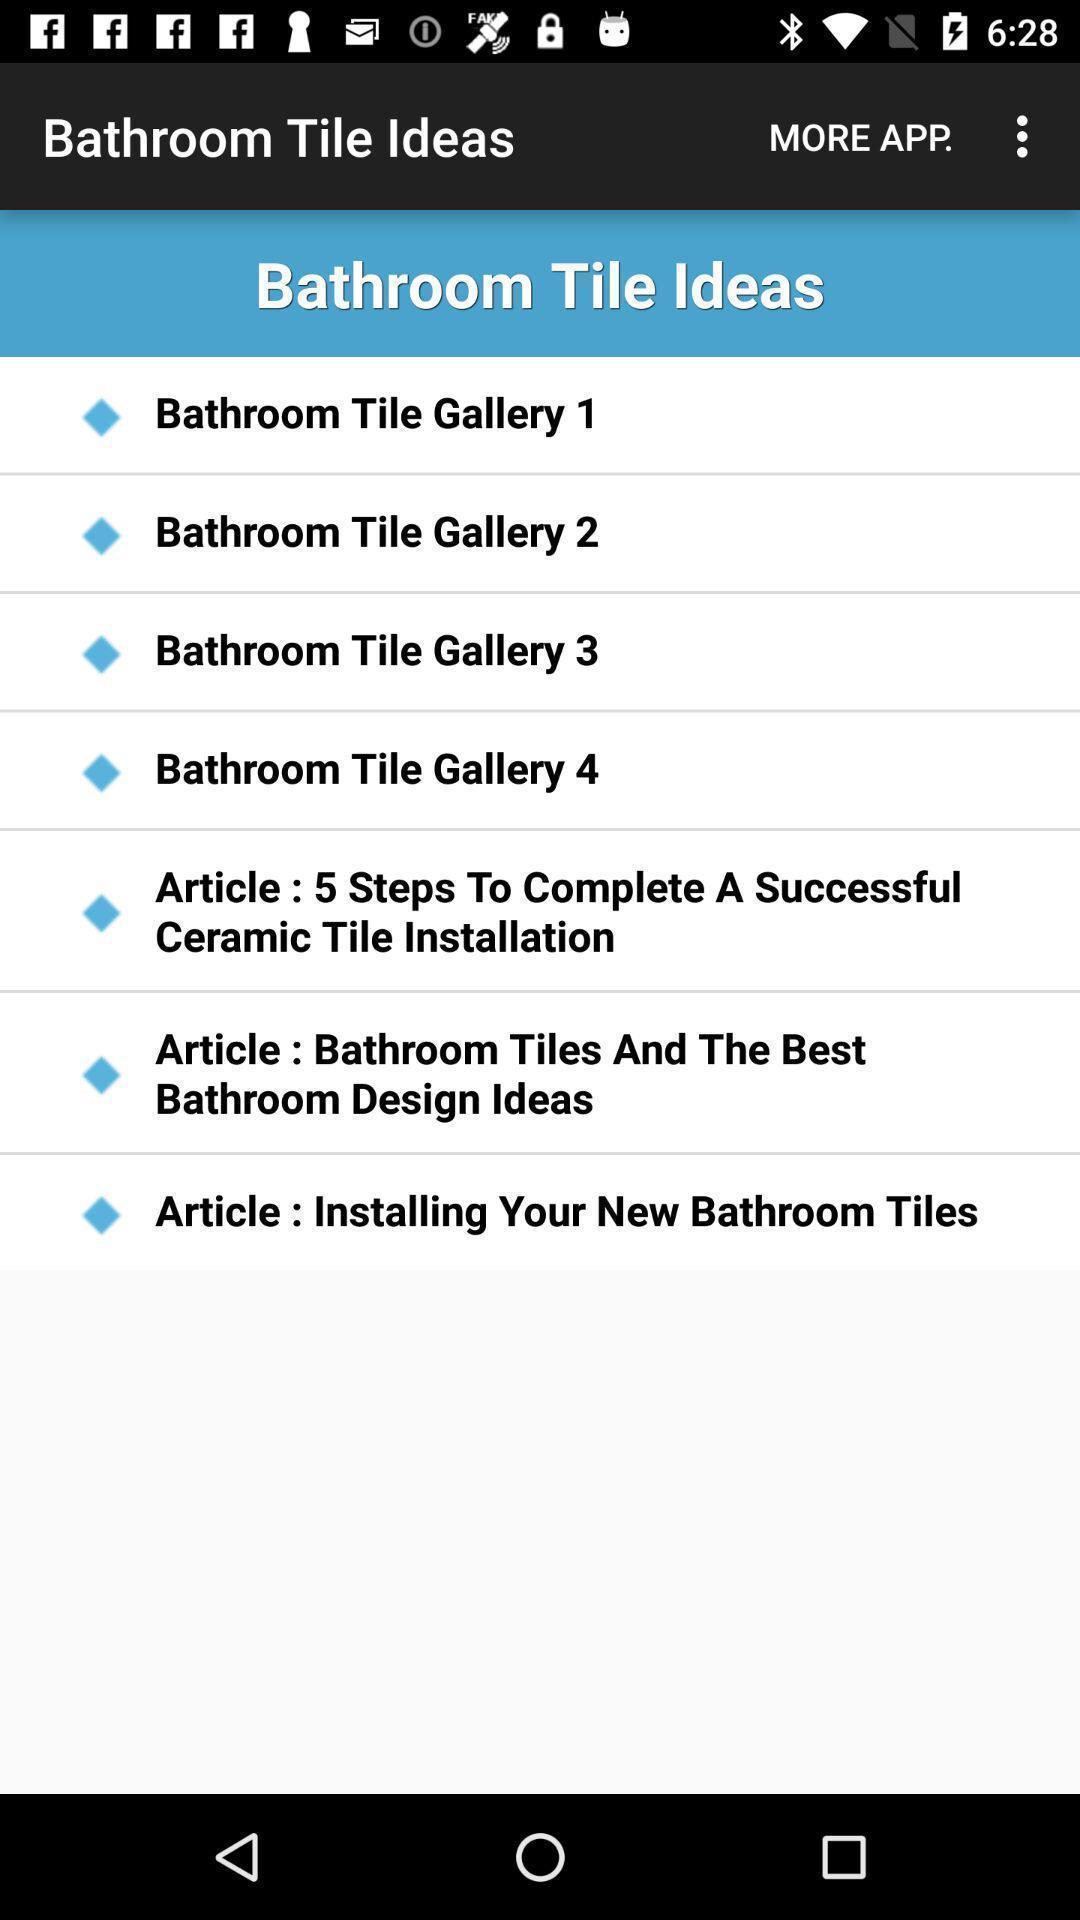Explain the elements present in this screenshot. Various ideas displayed of interior decoration app. 